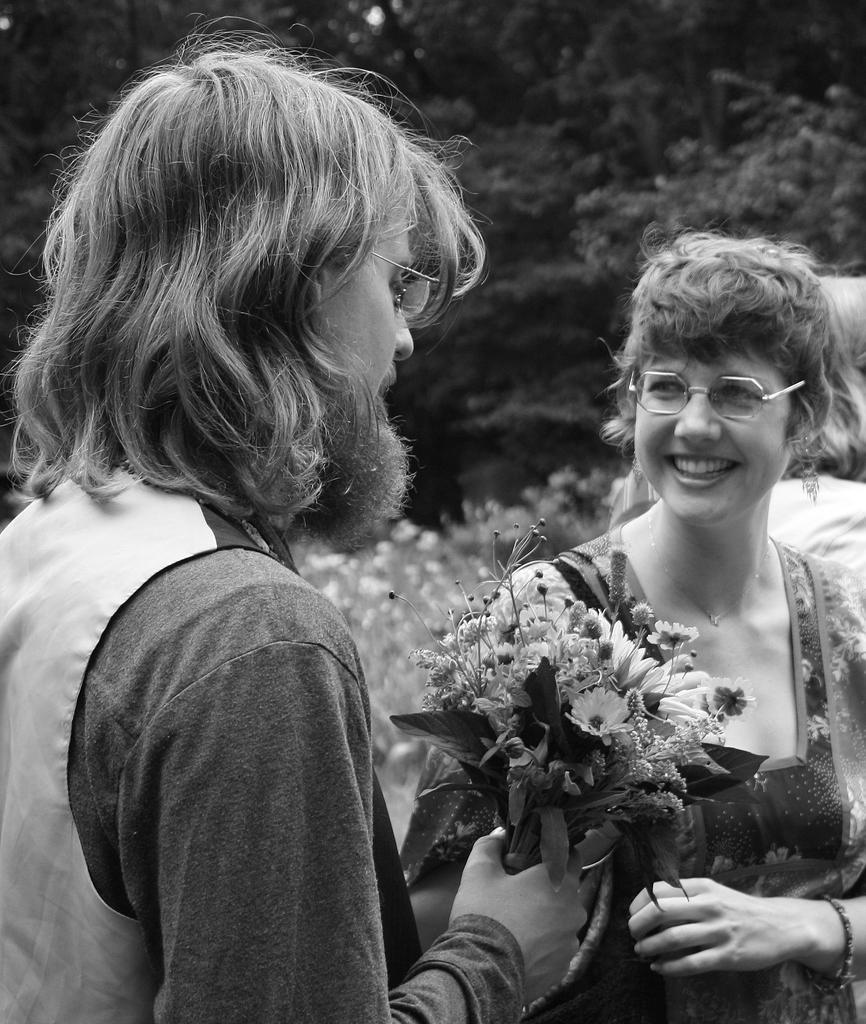In one or two sentences, can you explain what this image depicts? In this black and white image, we can see persons wearing clothes. There is a person on the left side of the image holding flowers with his hand. In the background, there are some trees. 